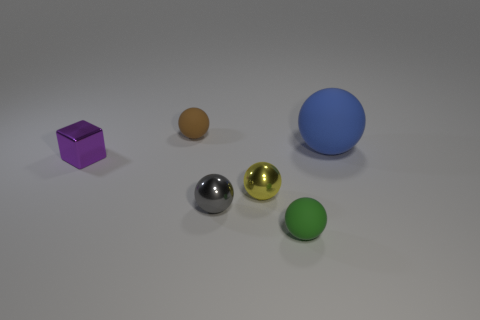Subtract all large blue balls. How many balls are left? 4 Add 1 big yellow rubber cylinders. How many objects exist? 7 Subtract 3 balls. How many balls are left? 2 Subtract all green balls. How many balls are left? 4 Subtract all balls. How many objects are left? 1 Subtract all green balls. Subtract all brown blocks. How many balls are left? 4 Subtract all tiny gray objects. Subtract all cubes. How many objects are left? 4 Add 1 metal blocks. How many metal blocks are left? 2 Add 1 small cyan rubber balls. How many small cyan rubber balls exist? 1 Subtract 0 yellow cubes. How many objects are left? 6 